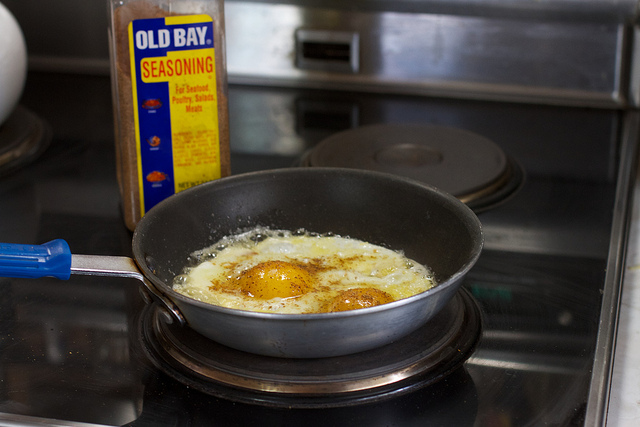Read all the text in this image. OLD BAY SEASONING 